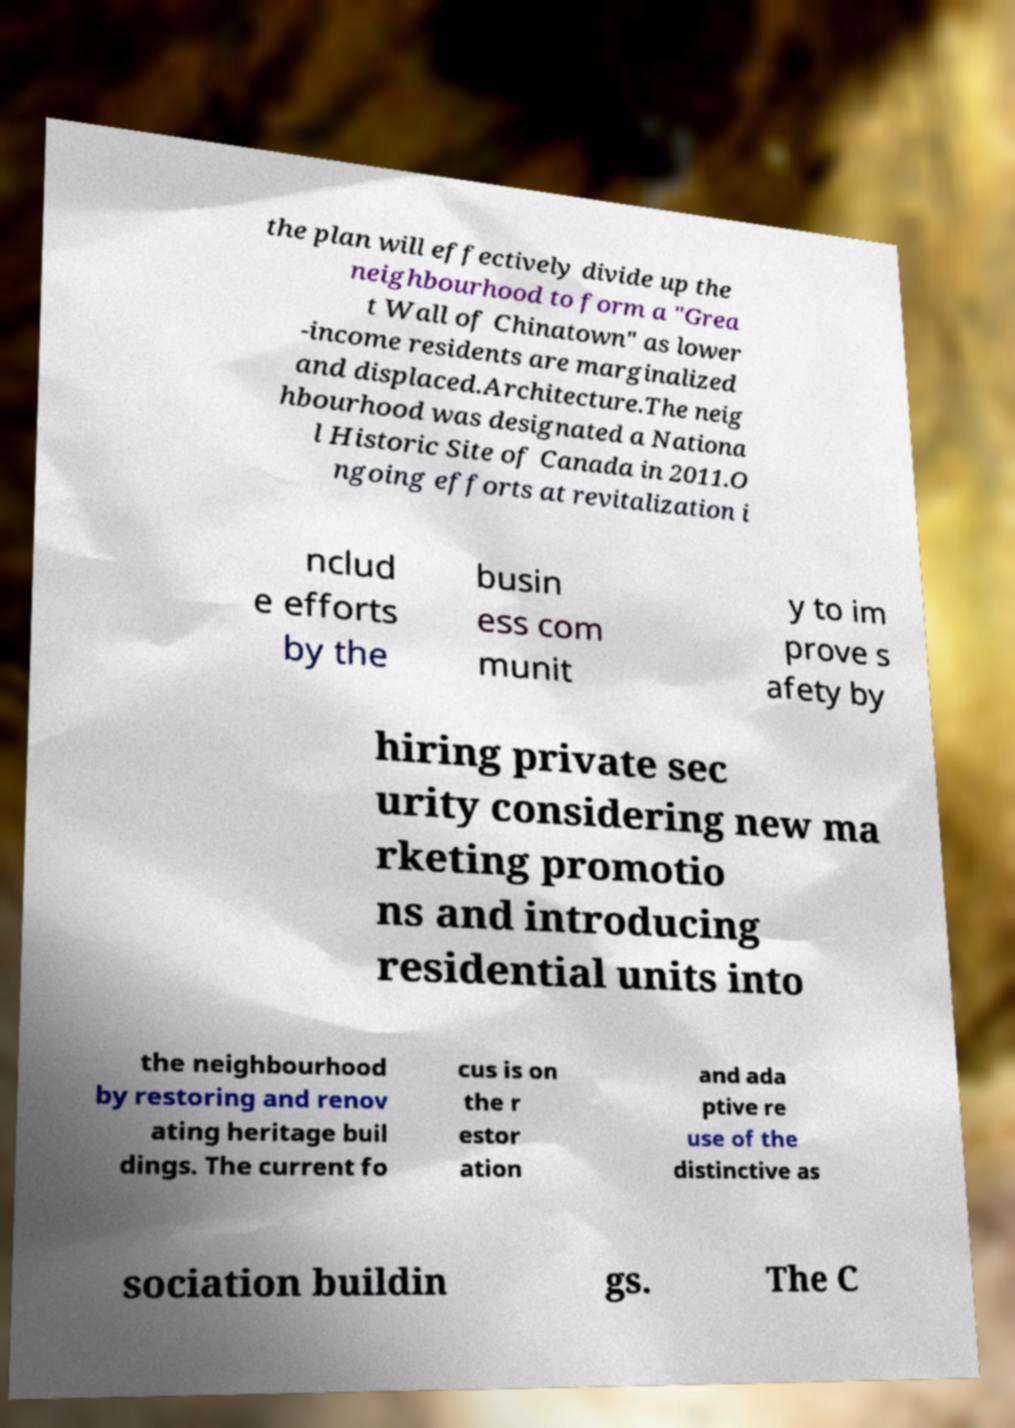Can you accurately transcribe the text from the provided image for me? the plan will effectively divide up the neighbourhood to form a "Grea t Wall of Chinatown" as lower -income residents are marginalized and displaced.Architecture.The neig hbourhood was designated a Nationa l Historic Site of Canada in 2011.O ngoing efforts at revitalization i nclud e efforts by the busin ess com munit y to im prove s afety by hiring private sec urity considering new ma rketing promotio ns and introducing residential units into the neighbourhood by restoring and renov ating heritage buil dings. The current fo cus is on the r estor ation and ada ptive re use of the distinctive as sociation buildin gs. The C 